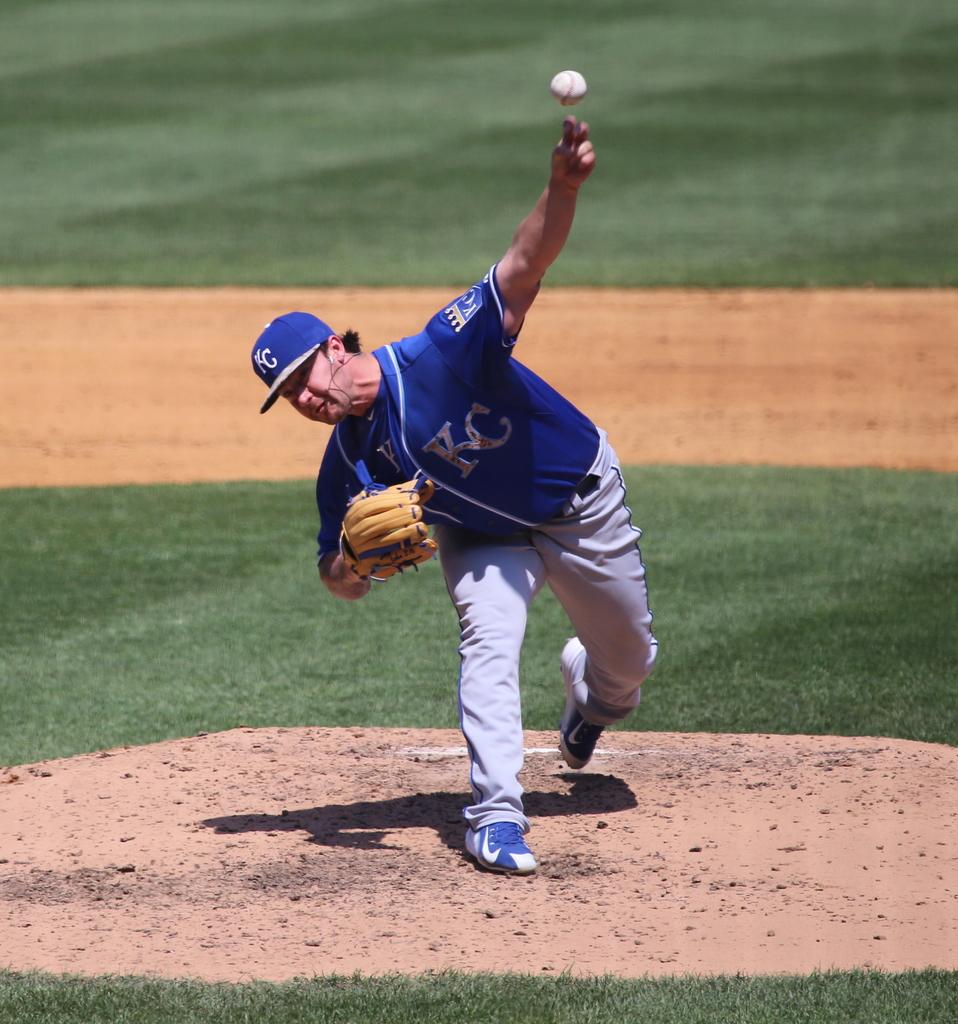What team jersey is this guy wearing?
Offer a very short reply. Kc. What initials are written on the blue shirt?
Offer a very short reply. Kc. 